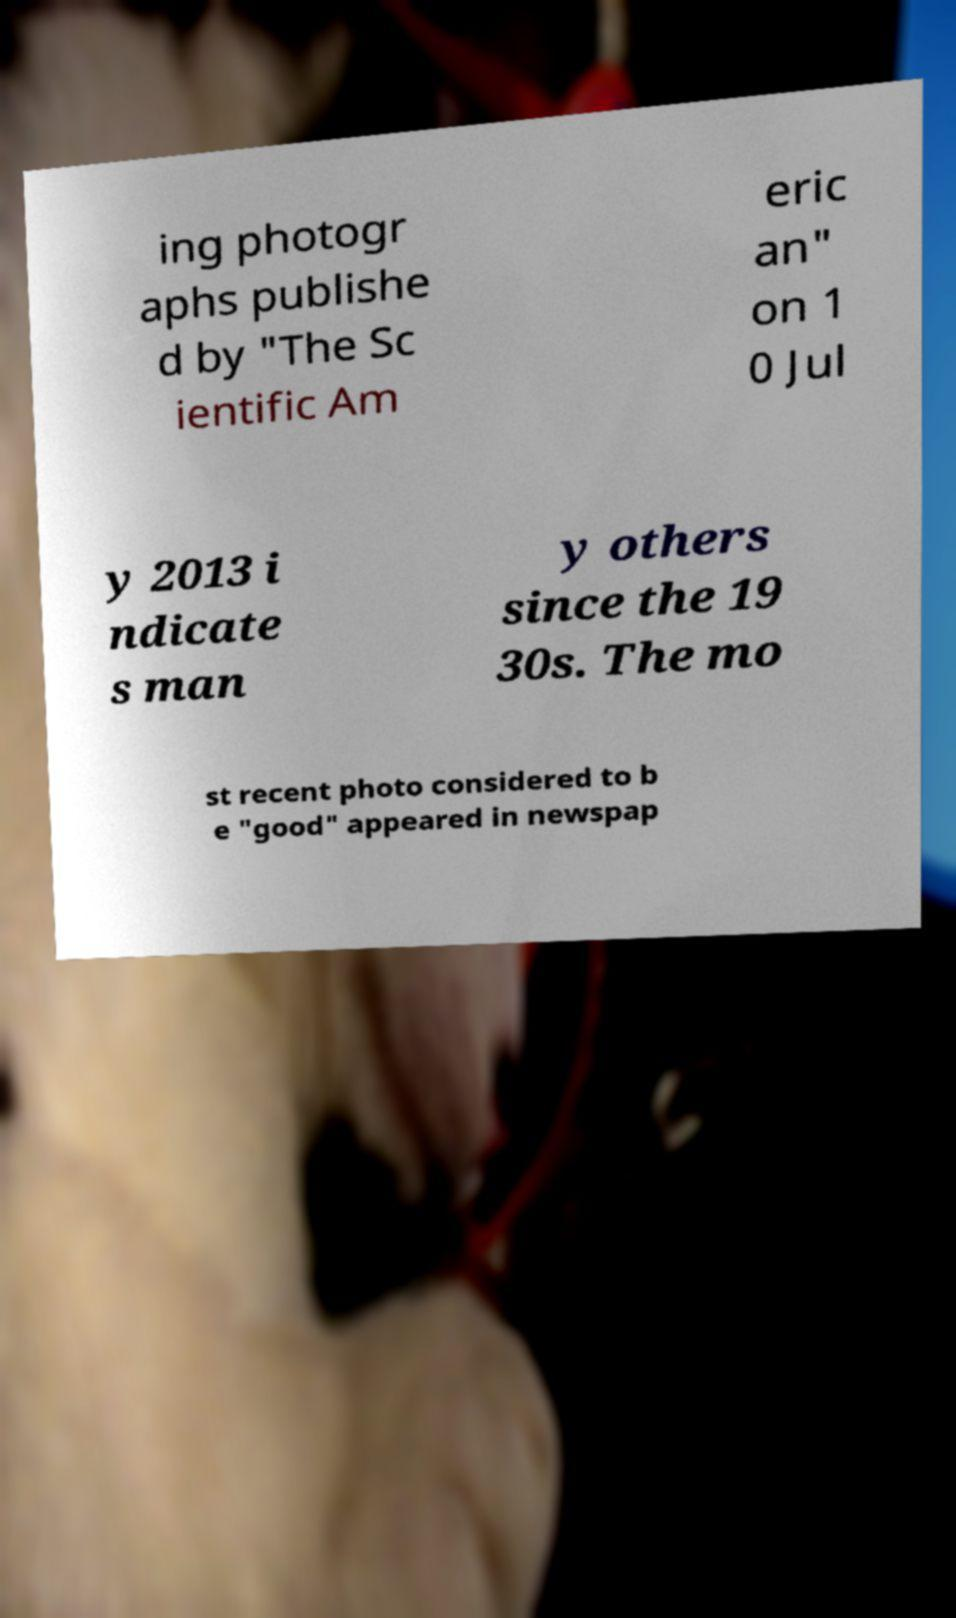Can you accurately transcribe the text from the provided image for me? ing photogr aphs publishe d by "The Sc ientific Am eric an" on 1 0 Jul y 2013 i ndicate s man y others since the 19 30s. The mo st recent photo considered to b e "good" appeared in newspap 